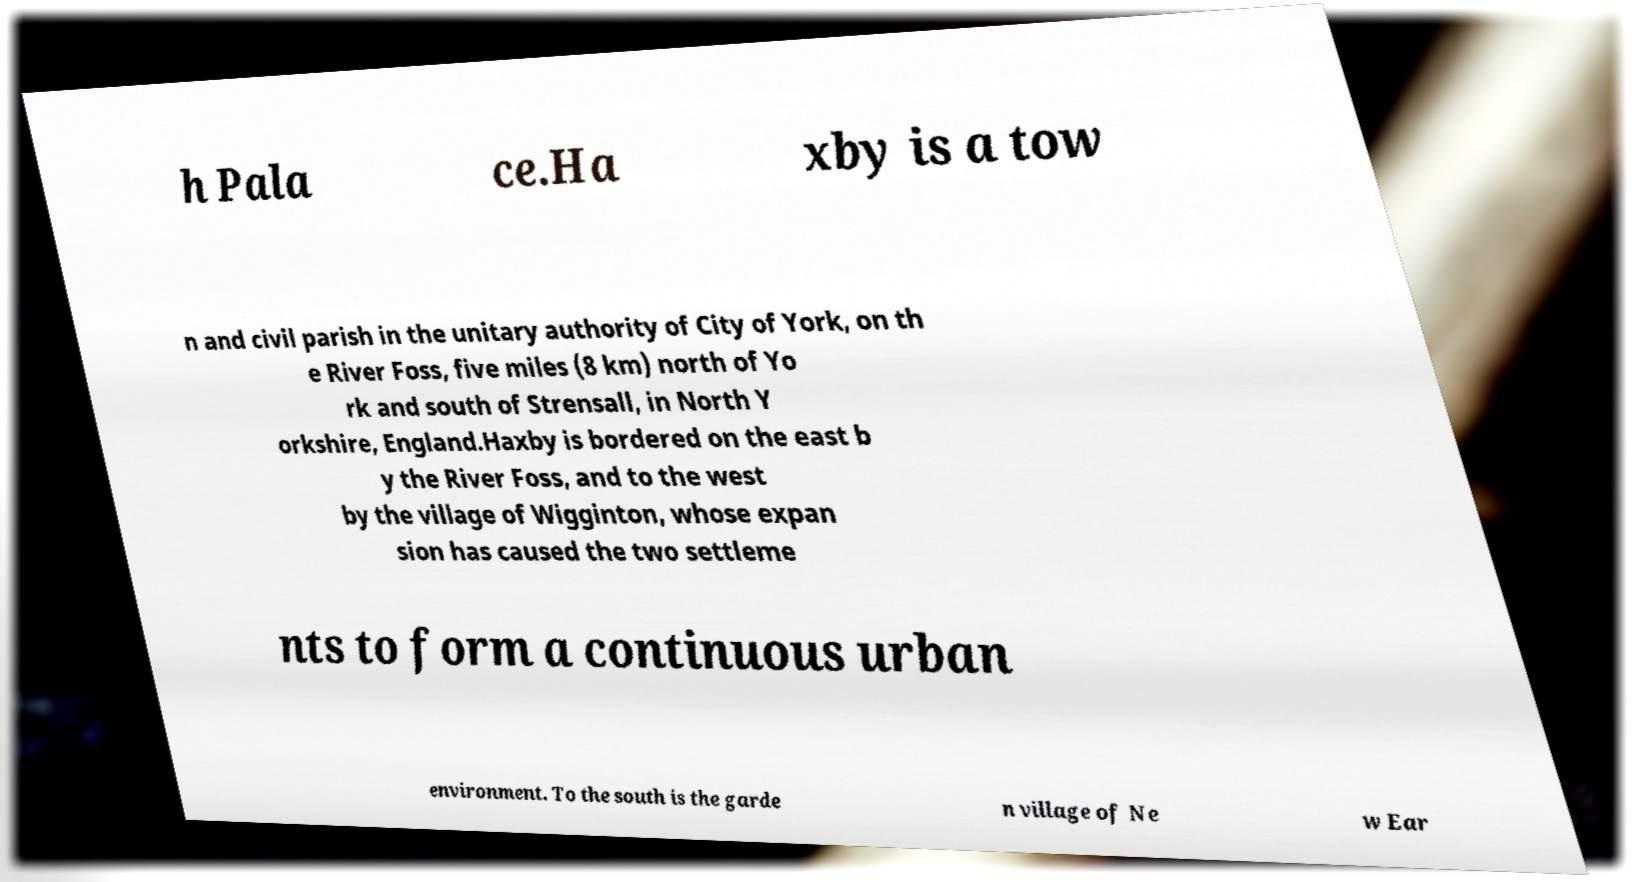For documentation purposes, I need the text within this image transcribed. Could you provide that? h Pala ce.Ha xby is a tow n and civil parish in the unitary authority of City of York, on th e River Foss, five miles (8 km) north of Yo rk and south of Strensall, in North Y orkshire, England.Haxby is bordered on the east b y the River Foss, and to the west by the village of Wigginton, whose expan sion has caused the two settleme nts to form a continuous urban environment. To the south is the garde n village of Ne w Ear 